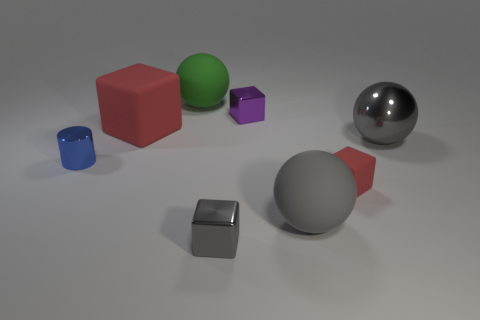Add 1 gray metal blocks. How many objects exist? 9 Subtract all cylinders. How many objects are left? 7 Subtract all large red things. Subtract all metal cylinders. How many objects are left? 6 Add 1 big green objects. How many big green objects are left? 2 Add 1 green balls. How many green balls exist? 2 Subtract 0 gray cylinders. How many objects are left? 8 